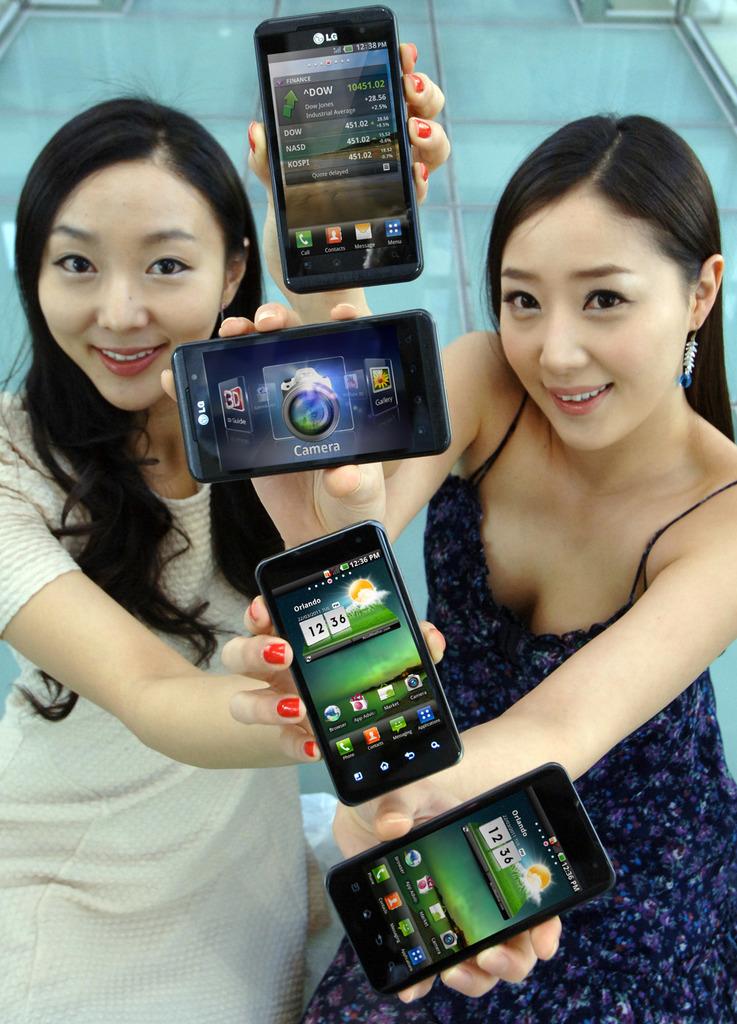What is the time on the third phone?
Keep it short and to the point. 12:36. Who makes these phones?
Provide a succinct answer. Lg. 